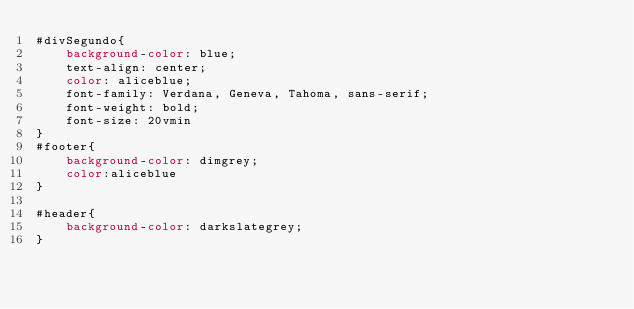<code> <loc_0><loc_0><loc_500><loc_500><_CSS_>#divSegundo{
    background-color: blue; 
    text-align: center; 
    color: aliceblue; 
    font-family: Verdana, Geneva, Tahoma, sans-serif; 
    font-weight: bold; 
    font-size: 20vmin
}
#footer{
    background-color: dimgrey;
    color:aliceblue
}

#header{
    background-color: darkslategrey;
}</code> 